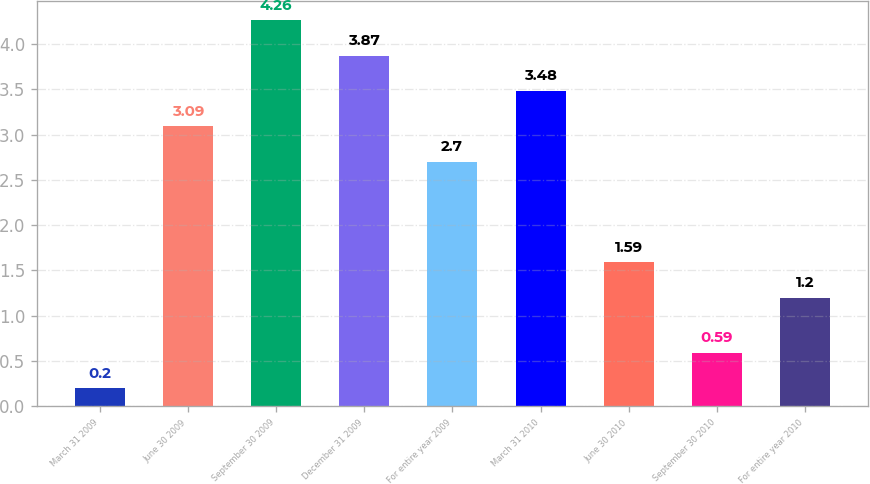Convert chart to OTSL. <chart><loc_0><loc_0><loc_500><loc_500><bar_chart><fcel>March 31 2009<fcel>June 30 2009<fcel>September 30 2009<fcel>December 31 2009<fcel>For entire year 2009<fcel>March 31 2010<fcel>June 30 2010<fcel>September 30 2010<fcel>For entire year 2010<nl><fcel>0.2<fcel>3.09<fcel>4.26<fcel>3.87<fcel>2.7<fcel>3.48<fcel>1.59<fcel>0.59<fcel>1.2<nl></chart> 